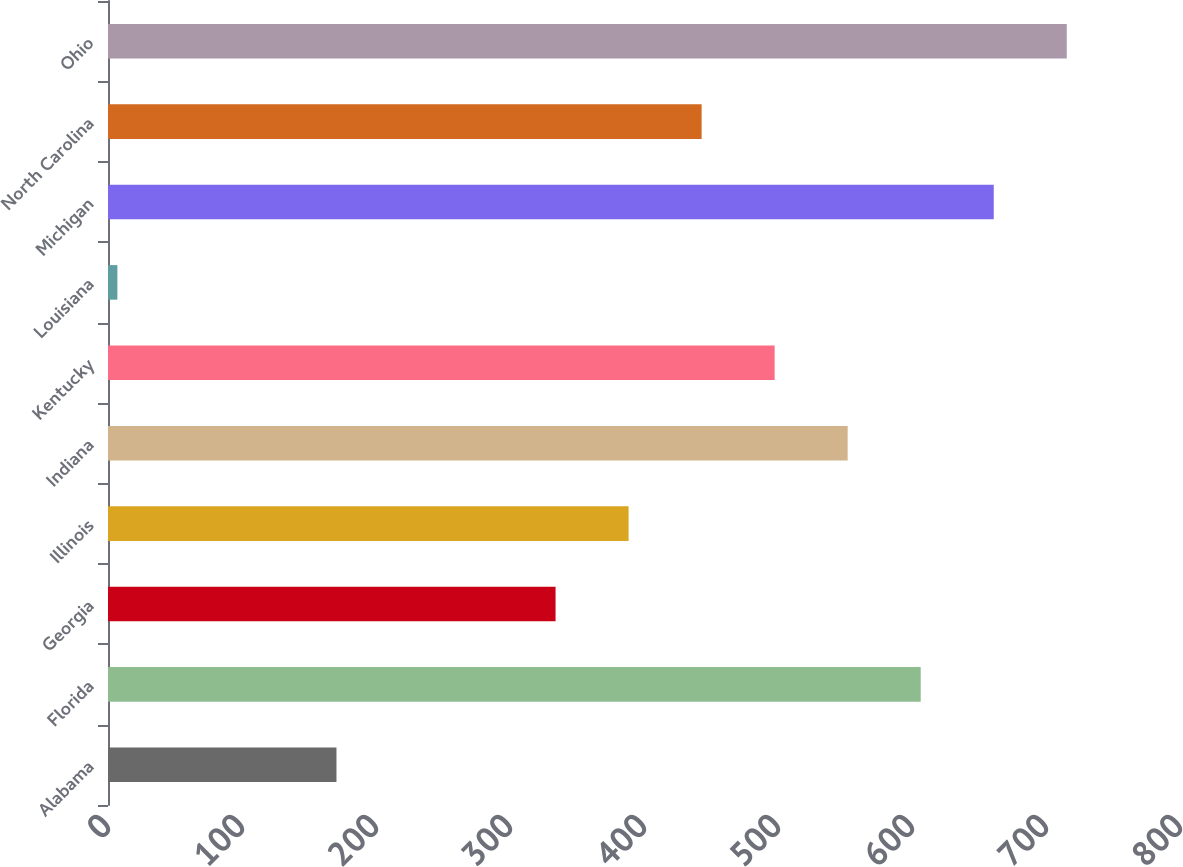Convert chart. <chart><loc_0><loc_0><loc_500><loc_500><bar_chart><fcel>Alabama<fcel>Florida<fcel>Georgia<fcel>Illinois<fcel>Indiana<fcel>Kentucky<fcel>Louisiana<fcel>Michigan<fcel>North Carolina<fcel>Ohio<nl><fcel>170.5<fcel>606.5<fcel>334<fcel>388.5<fcel>552<fcel>497.5<fcel>7<fcel>661<fcel>443<fcel>715.5<nl></chart> 